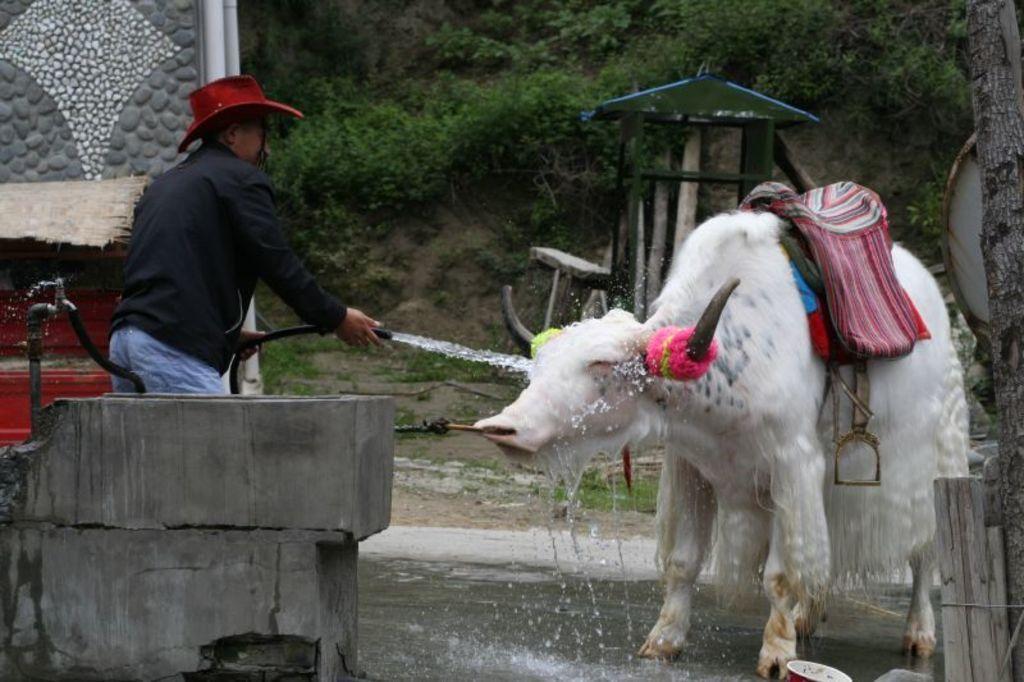Can you describe this image briefly? In this picture I can observe an animal on the right side which is looking like a cow. This animal is in white color. On the left side I can observe a man wearing red color hat. In the background there are some plants on the ground. 